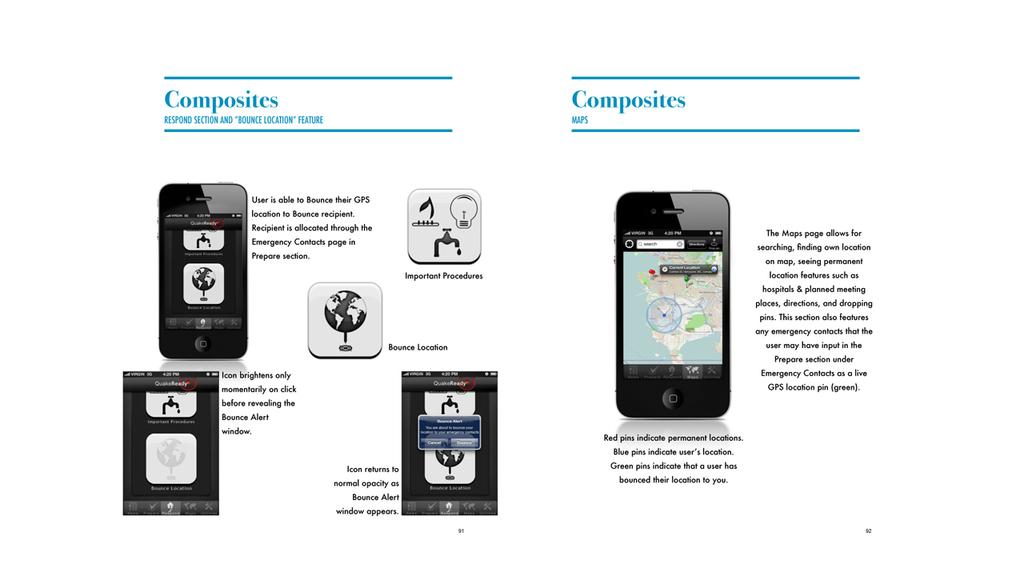<image>
Give a short and clear explanation of the subsequent image. Bounce location features are being explained for cell phone use. 